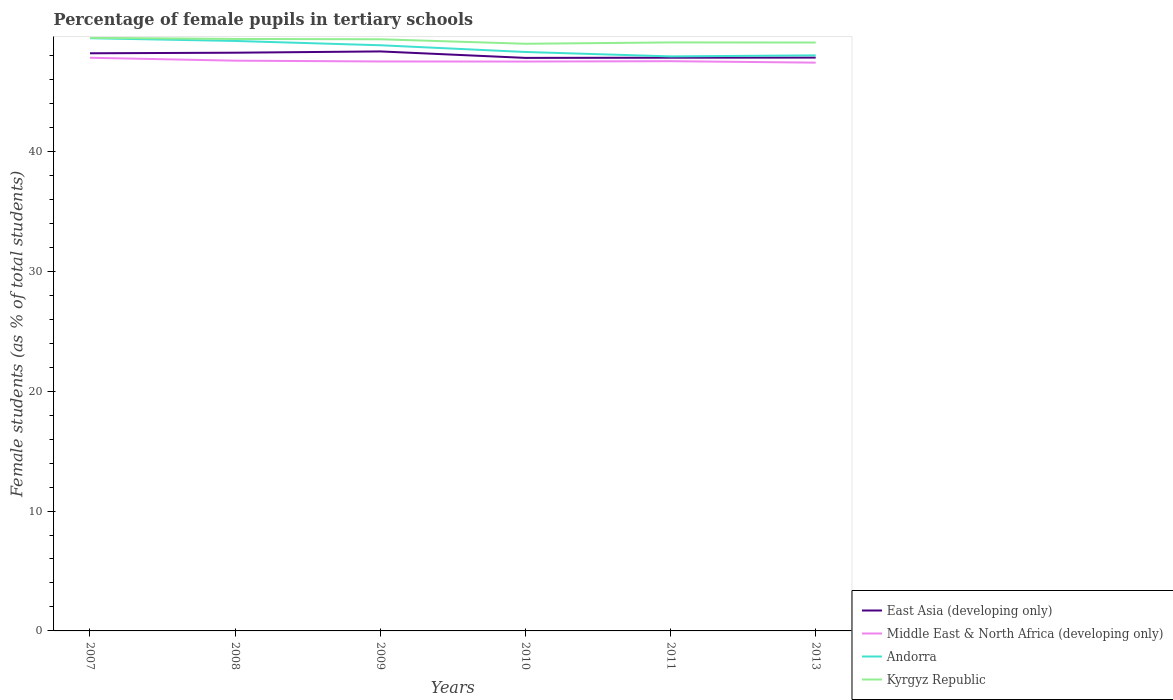How many different coloured lines are there?
Make the answer very short. 4. Is the number of lines equal to the number of legend labels?
Keep it short and to the point. Yes. Across all years, what is the maximum percentage of female pupils in tertiary schools in East Asia (developing only)?
Your response must be concise. 47.8. What is the total percentage of female pupils in tertiary schools in East Asia (developing only) in the graph?
Make the answer very short. 0.36. What is the difference between the highest and the second highest percentage of female pupils in tertiary schools in East Asia (developing only)?
Your response must be concise. 0.54. Is the percentage of female pupils in tertiary schools in Kyrgyz Republic strictly greater than the percentage of female pupils in tertiary schools in Middle East & North Africa (developing only) over the years?
Your answer should be compact. No. How many lines are there?
Give a very brief answer. 4. How many years are there in the graph?
Give a very brief answer. 6. What is the difference between two consecutive major ticks on the Y-axis?
Offer a terse response. 10. Are the values on the major ticks of Y-axis written in scientific E-notation?
Give a very brief answer. No. Does the graph contain any zero values?
Keep it short and to the point. No. Does the graph contain grids?
Your answer should be compact. No. Where does the legend appear in the graph?
Keep it short and to the point. Bottom right. How many legend labels are there?
Ensure brevity in your answer.  4. What is the title of the graph?
Provide a succinct answer. Percentage of female pupils in tertiary schools. What is the label or title of the X-axis?
Make the answer very short. Years. What is the label or title of the Y-axis?
Provide a succinct answer. Female students (as % of total students). What is the Female students (as % of total students) of East Asia (developing only) in 2007?
Your answer should be compact. 48.18. What is the Female students (as % of total students) in Middle East & North Africa (developing only) in 2007?
Provide a succinct answer. 47.81. What is the Female students (as % of total students) of Andorra in 2007?
Provide a succinct answer. 49.44. What is the Female students (as % of total students) in Kyrgyz Republic in 2007?
Provide a short and direct response. 49.47. What is the Female students (as % of total students) of East Asia (developing only) in 2008?
Offer a terse response. 48.23. What is the Female students (as % of total students) of Middle East & North Africa (developing only) in 2008?
Provide a succinct answer. 47.56. What is the Female students (as % of total students) of Andorra in 2008?
Ensure brevity in your answer.  49.21. What is the Female students (as % of total students) in Kyrgyz Republic in 2008?
Keep it short and to the point. 49.37. What is the Female students (as % of total students) of East Asia (developing only) in 2009?
Give a very brief answer. 48.34. What is the Female students (as % of total students) of Middle East & North Africa (developing only) in 2009?
Your answer should be compact. 47.5. What is the Female students (as % of total students) in Andorra in 2009?
Provide a succinct answer. 48.85. What is the Female students (as % of total students) in Kyrgyz Republic in 2009?
Ensure brevity in your answer.  49.35. What is the Female students (as % of total students) in East Asia (developing only) in 2010?
Offer a terse response. 47.8. What is the Female students (as % of total students) of Middle East & North Africa (developing only) in 2010?
Give a very brief answer. 47.49. What is the Female students (as % of total students) of Andorra in 2010?
Provide a short and direct response. 48.29. What is the Female students (as % of total students) in Kyrgyz Republic in 2010?
Keep it short and to the point. 48.97. What is the Female students (as % of total students) in East Asia (developing only) in 2011?
Your response must be concise. 47.81. What is the Female students (as % of total students) in Middle East & North Africa (developing only) in 2011?
Make the answer very short. 47.52. What is the Female students (as % of total students) of Andorra in 2011?
Your answer should be compact. 47.92. What is the Female students (as % of total students) of Kyrgyz Republic in 2011?
Make the answer very short. 49.09. What is the Female students (as % of total students) of East Asia (developing only) in 2013?
Ensure brevity in your answer.  47.82. What is the Female students (as % of total students) of Middle East & North Africa (developing only) in 2013?
Ensure brevity in your answer.  47.4. What is the Female students (as % of total students) of Andorra in 2013?
Keep it short and to the point. 48.01. What is the Female students (as % of total students) of Kyrgyz Republic in 2013?
Ensure brevity in your answer.  49.08. Across all years, what is the maximum Female students (as % of total students) of East Asia (developing only)?
Your answer should be compact. 48.34. Across all years, what is the maximum Female students (as % of total students) in Middle East & North Africa (developing only)?
Make the answer very short. 47.81. Across all years, what is the maximum Female students (as % of total students) in Andorra?
Give a very brief answer. 49.44. Across all years, what is the maximum Female students (as % of total students) in Kyrgyz Republic?
Offer a terse response. 49.47. Across all years, what is the minimum Female students (as % of total students) of East Asia (developing only)?
Provide a short and direct response. 47.8. Across all years, what is the minimum Female students (as % of total students) of Middle East & North Africa (developing only)?
Make the answer very short. 47.4. Across all years, what is the minimum Female students (as % of total students) in Andorra?
Give a very brief answer. 47.92. Across all years, what is the minimum Female students (as % of total students) of Kyrgyz Republic?
Offer a terse response. 48.97. What is the total Female students (as % of total students) of East Asia (developing only) in the graph?
Offer a terse response. 288.17. What is the total Female students (as % of total students) of Middle East & North Africa (developing only) in the graph?
Provide a succinct answer. 285.28. What is the total Female students (as % of total students) in Andorra in the graph?
Provide a succinct answer. 291.71. What is the total Female students (as % of total students) in Kyrgyz Republic in the graph?
Keep it short and to the point. 295.33. What is the difference between the Female students (as % of total students) of East Asia (developing only) in 2007 and that in 2008?
Give a very brief answer. -0.05. What is the difference between the Female students (as % of total students) of Middle East & North Africa (developing only) in 2007 and that in 2008?
Your answer should be compact. 0.24. What is the difference between the Female students (as % of total students) of Andorra in 2007 and that in 2008?
Offer a terse response. 0.23. What is the difference between the Female students (as % of total students) in Kyrgyz Republic in 2007 and that in 2008?
Give a very brief answer. 0.1. What is the difference between the Female students (as % of total students) in East Asia (developing only) in 2007 and that in 2009?
Offer a terse response. -0.15. What is the difference between the Female students (as % of total students) of Middle East & North Africa (developing only) in 2007 and that in 2009?
Provide a succinct answer. 0.31. What is the difference between the Female students (as % of total students) of Andorra in 2007 and that in 2009?
Your response must be concise. 0.59. What is the difference between the Female students (as % of total students) of Kyrgyz Republic in 2007 and that in 2009?
Offer a very short reply. 0.12. What is the difference between the Female students (as % of total students) in East Asia (developing only) in 2007 and that in 2010?
Provide a short and direct response. 0.39. What is the difference between the Female students (as % of total students) in Middle East & North Africa (developing only) in 2007 and that in 2010?
Your answer should be compact. 0.32. What is the difference between the Female students (as % of total students) of Andorra in 2007 and that in 2010?
Your answer should be compact. 1.15. What is the difference between the Female students (as % of total students) in Kyrgyz Republic in 2007 and that in 2010?
Offer a very short reply. 0.5. What is the difference between the Female students (as % of total students) of East Asia (developing only) in 2007 and that in 2011?
Your response must be concise. 0.37. What is the difference between the Female students (as % of total students) of Middle East & North Africa (developing only) in 2007 and that in 2011?
Provide a succinct answer. 0.29. What is the difference between the Female students (as % of total students) in Andorra in 2007 and that in 2011?
Give a very brief answer. 1.52. What is the difference between the Female students (as % of total students) of Kyrgyz Republic in 2007 and that in 2011?
Your response must be concise. 0.38. What is the difference between the Female students (as % of total students) of East Asia (developing only) in 2007 and that in 2013?
Offer a very short reply. 0.36. What is the difference between the Female students (as % of total students) of Middle East & North Africa (developing only) in 2007 and that in 2013?
Keep it short and to the point. 0.41. What is the difference between the Female students (as % of total students) in Andorra in 2007 and that in 2013?
Keep it short and to the point. 1.43. What is the difference between the Female students (as % of total students) in Kyrgyz Republic in 2007 and that in 2013?
Your answer should be compact. 0.39. What is the difference between the Female students (as % of total students) of East Asia (developing only) in 2008 and that in 2009?
Your response must be concise. -0.11. What is the difference between the Female students (as % of total students) of Middle East & North Africa (developing only) in 2008 and that in 2009?
Your answer should be very brief. 0.07. What is the difference between the Female students (as % of total students) in Andorra in 2008 and that in 2009?
Provide a succinct answer. 0.36. What is the difference between the Female students (as % of total students) of Kyrgyz Republic in 2008 and that in 2009?
Give a very brief answer. 0.02. What is the difference between the Female students (as % of total students) of East Asia (developing only) in 2008 and that in 2010?
Ensure brevity in your answer.  0.43. What is the difference between the Female students (as % of total students) in Middle East & North Africa (developing only) in 2008 and that in 2010?
Offer a very short reply. 0.07. What is the difference between the Female students (as % of total students) in Andorra in 2008 and that in 2010?
Your response must be concise. 0.92. What is the difference between the Female students (as % of total students) of Kyrgyz Republic in 2008 and that in 2010?
Your answer should be very brief. 0.4. What is the difference between the Female students (as % of total students) of East Asia (developing only) in 2008 and that in 2011?
Provide a short and direct response. 0.42. What is the difference between the Female students (as % of total students) of Middle East & North Africa (developing only) in 2008 and that in 2011?
Provide a succinct answer. 0.04. What is the difference between the Female students (as % of total students) of Andorra in 2008 and that in 2011?
Your response must be concise. 1.29. What is the difference between the Female students (as % of total students) in Kyrgyz Republic in 2008 and that in 2011?
Your response must be concise. 0.29. What is the difference between the Female students (as % of total students) of East Asia (developing only) in 2008 and that in 2013?
Provide a succinct answer. 0.41. What is the difference between the Female students (as % of total students) in Middle East & North Africa (developing only) in 2008 and that in 2013?
Keep it short and to the point. 0.17. What is the difference between the Female students (as % of total students) of Andorra in 2008 and that in 2013?
Make the answer very short. 1.2. What is the difference between the Female students (as % of total students) of Kyrgyz Republic in 2008 and that in 2013?
Your answer should be compact. 0.3. What is the difference between the Female students (as % of total students) in East Asia (developing only) in 2009 and that in 2010?
Make the answer very short. 0.54. What is the difference between the Female students (as % of total students) of Middle East & North Africa (developing only) in 2009 and that in 2010?
Offer a terse response. 0.01. What is the difference between the Female students (as % of total students) of Andorra in 2009 and that in 2010?
Keep it short and to the point. 0.56. What is the difference between the Female students (as % of total students) of Kyrgyz Republic in 2009 and that in 2010?
Ensure brevity in your answer.  0.38. What is the difference between the Female students (as % of total students) of East Asia (developing only) in 2009 and that in 2011?
Your answer should be very brief. 0.52. What is the difference between the Female students (as % of total students) of Middle East & North Africa (developing only) in 2009 and that in 2011?
Offer a very short reply. -0.02. What is the difference between the Female students (as % of total students) of Andorra in 2009 and that in 2011?
Provide a succinct answer. 0.93. What is the difference between the Female students (as % of total students) of Kyrgyz Republic in 2009 and that in 2011?
Make the answer very short. 0.26. What is the difference between the Female students (as % of total students) in East Asia (developing only) in 2009 and that in 2013?
Give a very brief answer. 0.52. What is the difference between the Female students (as % of total students) of Middle East & North Africa (developing only) in 2009 and that in 2013?
Give a very brief answer. 0.1. What is the difference between the Female students (as % of total students) in Andorra in 2009 and that in 2013?
Offer a very short reply. 0.84. What is the difference between the Female students (as % of total students) in Kyrgyz Republic in 2009 and that in 2013?
Provide a succinct answer. 0.27. What is the difference between the Female students (as % of total students) in East Asia (developing only) in 2010 and that in 2011?
Provide a short and direct response. -0.02. What is the difference between the Female students (as % of total students) in Middle East & North Africa (developing only) in 2010 and that in 2011?
Your response must be concise. -0.03. What is the difference between the Female students (as % of total students) in Andorra in 2010 and that in 2011?
Offer a terse response. 0.37. What is the difference between the Female students (as % of total students) in Kyrgyz Republic in 2010 and that in 2011?
Your answer should be compact. -0.11. What is the difference between the Female students (as % of total students) in East Asia (developing only) in 2010 and that in 2013?
Provide a short and direct response. -0.02. What is the difference between the Female students (as % of total students) in Middle East & North Africa (developing only) in 2010 and that in 2013?
Your answer should be compact. 0.09. What is the difference between the Female students (as % of total students) of Andorra in 2010 and that in 2013?
Offer a terse response. 0.28. What is the difference between the Female students (as % of total students) in Kyrgyz Republic in 2010 and that in 2013?
Provide a succinct answer. -0.1. What is the difference between the Female students (as % of total students) of East Asia (developing only) in 2011 and that in 2013?
Make the answer very short. -0.01. What is the difference between the Female students (as % of total students) in Middle East & North Africa (developing only) in 2011 and that in 2013?
Provide a succinct answer. 0.12. What is the difference between the Female students (as % of total students) of Andorra in 2011 and that in 2013?
Your answer should be compact. -0.09. What is the difference between the Female students (as % of total students) in Kyrgyz Republic in 2011 and that in 2013?
Give a very brief answer. 0.01. What is the difference between the Female students (as % of total students) of East Asia (developing only) in 2007 and the Female students (as % of total students) of Middle East & North Africa (developing only) in 2008?
Ensure brevity in your answer.  0.62. What is the difference between the Female students (as % of total students) in East Asia (developing only) in 2007 and the Female students (as % of total students) in Andorra in 2008?
Provide a succinct answer. -1.03. What is the difference between the Female students (as % of total students) of East Asia (developing only) in 2007 and the Female students (as % of total students) of Kyrgyz Republic in 2008?
Offer a terse response. -1.19. What is the difference between the Female students (as % of total students) in Middle East & North Africa (developing only) in 2007 and the Female students (as % of total students) in Andorra in 2008?
Your response must be concise. -1.4. What is the difference between the Female students (as % of total students) of Middle East & North Africa (developing only) in 2007 and the Female students (as % of total students) of Kyrgyz Republic in 2008?
Give a very brief answer. -1.57. What is the difference between the Female students (as % of total students) of Andorra in 2007 and the Female students (as % of total students) of Kyrgyz Republic in 2008?
Offer a terse response. 0.06. What is the difference between the Female students (as % of total students) in East Asia (developing only) in 2007 and the Female students (as % of total students) in Middle East & North Africa (developing only) in 2009?
Offer a terse response. 0.68. What is the difference between the Female students (as % of total students) of East Asia (developing only) in 2007 and the Female students (as % of total students) of Andorra in 2009?
Give a very brief answer. -0.67. What is the difference between the Female students (as % of total students) of East Asia (developing only) in 2007 and the Female students (as % of total students) of Kyrgyz Republic in 2009?
Your answer should be compact. -1.17. What is the difference between the Female students (as % of total students) of Middle East & North Africa (developing only) in 2007 and the Female students (as % of total students) of Andorra in 2009?
Provide a short and direct response. -1.04. What is the difference between the Female students (as % of total students) in Middle East & North Africa (developing only) in 2007 and the Female students (as % of total students) in Kyrgyz Republic in 2009?
Your answer should be very brief. -1.54. What is the difference between the Female students (as % of total students) of Andorra in 2007 and the Female students (as % of total students) of Kyrgyz Republic in 2009?
Your answer should be very brief. 0.09. What is the difference between the Female students (as % of total students) of East Asia (developing only) in 2007 and the Female students (as % of total students) of Middle East & North Africa (developing only) in 2010?
Offer a terse response. 0.69. What is the difference between the Female students (as % of total students) of East Asia (developing only) in 2007 and the Female students (as % of total students) of Andorra in 2010?
Your response must be concise. -0.11. What is the difference between the Female students (as % of total students) in East Asia (developing only) in 2007 and the Female students (as % of total students) in Kyrgyz Republic in 2010?
Keep it short and to the point. -0.79. What is the difference between the Female students (as % of total students) in Middle East & North Africa (developing only) in 2007 and the Female students (as % of total students) in Andorra in 2010?
Ensure brevity in your answer.  -0.48. What is the difference between the Female students (as % of total students) of Middle East & North Africa (developing only) in 2007 and the Female students (as % of total students) of Kyrgyz Republic in 2010?
Keep it short and to the point. -1.17. What is the difference between the Female students (as % of total students) of Andorra in 2007 and the Female students (as % of total students) of Kyrgyz Republic in 2010?
Offer a very short reply. 0.46. What is the difference between the Female students (as % of total students) in East Asia (developing only) in 2007 and the Female students (as % of total students) in Middle East & North Africa (developing only) in 2011?
Offer a terse response. 0.66. What is the difference between the Female students (as % of total students) of East Asia (developing only) in 2007 and the Female students (as % of total students) of Andorra in 2011?
Give a very brief answer. 0.26. What is the difference between the Female students (as % of total students) of East Asia (developing only) in 2007 and the Female students (as % of total students) of Kyrgyz Republic in 2011?
Ensure brevity in your answer.  -0.91. What is the difference between the Female students (as % of total students) of Middle East & North Africa (developing only) in 2007 and the Female students (as % of total students) of Andorra in 2011?
Provide a short and direct response. -0.11. What is the difference between the Female students (as % of total students) in Middle East & North Africa (developing only) in 2007 and the Female students (as % of total students) in Kyrgyz Republic in 2011?
Keep it short and to the point. -1.28. What is the difference between the Female students (as % of total students) in Andorra in 2007 and the Female students (as % of total students) in Kyrgyz Republic in 2011?
Keep it short and to the point. 0.35. What is the difference between the Female students (as % of total students) in East Asia (developing only) in 2007 and the Female students (as % of total students) in Middle East & North Africa (developing only) in 2013?
Give a very brief answer. 0.78. What is the difference between the Female students (as % of total students) in East Asia (developing only) in 2007 and the Female students (as % of total students) in Andorra in 2013?
Provide a succinct answer. 0.17. What is the difference between the Female students (as % of total students) of East Asia (developing only) in 2007 and the Female students (as % of total students) of Kyrgyz Republic in 2013?
Your answer should be very brief. -0.9. What is the difference between the Female students (as % of total students) in Middle East & North Africa (developing only) in 2007 and the Female students (as % of total students) in Kyrgyz Republic in 2013?
Make the answer very short. -1.27. What is the difference between the Female students (as % of total students) in Andorra in 2007 and the Female students (as % of total students) in Kyrgyz Republic in 2013?
Give a very brief answer. 0.36. What is the difference between the Female students (as % of total students) of East Asia (developing only) in 2008 and the Female students (as % of total students) of Middle East & North Africa (developing only) in 2009?
Give a very brief answer. 0.73. What is the difference between the Female students (as % of total students) in East Asia (developing only) in 2008 and the Female students (as % of total students) in Andorra in 2009?
Your answer should be very brief. -0.62. What is the difference between the Female students (as % of total students) of East Asia (developing only) in 2008 and the Female students (as % of total students) of Kyrgyz Republic in 2009?
Ensure brevity in your answer.  -1.12. What is the difference between the Female students (as % of total students) of Middle East & North Africa (developing only) in 2008 and the Female students (as % of total students) of Andorra in 2009?
Offer a terse response. -1.29. What is the difference between the Female students (as % of total students) in Middle East & North Africa (developing only) in 2008 and the Female students (as % of total students) in Kyrgyz Republic in 2009?
Ensure brevity in your answer.  -1.78. What is the difference between the Female students (as % of total students) of Andorra in 2008 and the Female students (as % of total students) of Kyrgyz Republic in 2009?
Ensure brevity in your answer.  -0.14. What is the difference between the Female students (as % of total students) in East Asia (developing only) in 2008 and the Female students (as % of total students) in Middle East & North Africa (developing only) in 2010?
Give a very brief answer. 0.74. What is the difference between the Female students (as % of total students) in East Asia (developing only) in 2008 and the Female students (as % of total students) in Andorra in 2010?
Offer a terse response. -0.06. What is the difference between the Female students (as % of total students) in East Asia (developing only) in 2008 and the Female students (as % of total students) in Kyrgyz Republic in 2010?
Make the answer very short. -0.75. What is the difference between the Female students (as % of total students) of Middle East & North Africa (developing only) in 2008 and the Female students (as % of total students) of Andorra in 2010?
Your answer should be very brief. -0.72. What is the difference between the Female students (as % of total students) of Middle East & North Africa (developing only) in 2008 and the Female students (as % of total students) of Kyrgyz Republic in 2010?
Provide a succinct answer. -1.41. What is the difference between the Female students (as % of total students) of Andorra in 2008 and the Female students (as % of total students) of Kyrgyz Republic in 2010?
Make the answer very short. 0.23. What is the difference between the Female students (as % of total students) of East Asia (developing only) in 2008 and the Female students (as % of total students) of Middle East & North Africa (developing only) in 2011?
Your answer should be very brief. 0.71. What is the difference between the Female students (as % of total students) of East Asia (developing only) in 2008 and the Female students (as % of total students) of Andorra in 2011?
Offer a very short reply. 0.31. What is the difference between the Female students (as % of total students) of East Asia (developing only) in 2008 and the Female students (as % of total students) of Kyrgyz Republic in 2011?
Provide a succinct answer. -0.86. What is the difference between the Female students (as % of total students) of Middle East & North Africa (developing only) in 2008 and the Female students (as % of total students) of Andorra in 2011?
Offer a very short reply. -0.36. What is the difference between the Female students (as % of total students) of Middle East & North Africa (developing only) in 2008 and the Female students (as % of total students) of Kyrgyz Republic in 2011?
Make the answer very short. -1.52. What is the difference between the Female students (as % of total students) in Andorra in 2008 and the Female students (as % of total students) in Kyrgyz Republic in 2011?
Offer a terse response. 0.12. What is the difference between the Female students (as % of total students) of East Asia (developing only) in 2008 and the Female students (as % of total students) of Middle East & North Africa (developing only) in 2013?
Your answer should be very brief. 0.83. What is the difference between the Female students (as % of total students) of East Asia (developing only) in 2008 and the Female students (as % of total students) of Andorra in 2013?
Keep it short and to the point. 0.22. What is the difference between the Female students (as % of total students) in East Asia (developing only) in 2008 and the Female students (as % of total students) in Kyrgyz Republic in 2013?
Your response must be concise. -0.85. What is the difference between the Female students (as % of total students) of Middle East & North Africa (developing only) in 2008 and the Female students (as % of total students) of Andorra in 2013?
Offer a very short reply. -0.44. What is the difference between the Female students (as % of total students) of Middle East & North Africa (developing only) in 2008 and the Female students (as % of total students) of Kyrgyz Republic in 2013?
Offer a terse response. -1.51. What is the difference between the Female students (as % of total students) of Andorra in 2008 and the Female students (as % of total students) of Kyrgyz Republic in 2013?
Keep it short and to the point. 0.13. What is the difference between the Female students (as % of total students) in East Asia (developing only) in 2009 and the Female students (as % of total students) in Middle East & North Africa (developing only) in 2010?
Your response must be concise. 0.84. What is the difference between the Female students (as % of total students) in East Asia (developing only) in 2009 and the Female students (as % of total students) in Andorra in 2010?
Give a very brief answer. 0.05. What is the difference between the Female students (as % of total students) of East Asia (developing only) in 2009 and the Female students (as % of total students) of Kyrgyz Republic in 2010?
Provide a short and direct response. -0.64. What is the difference between the Female students (as % of total students) in Middle East & North Africa (developing only) in 2009 and the Female students (as % of total students) in Andorra in 2010?
Give a very brief answer. -0.79. What is the difference between the Female students (as % of total students) of Middle East & North Africa (developing only) in 2009 and the Female students (as % of total students) of Kyrgyz Republic in 2010?
Provide a succinct answer. -1.48. What is the difference between the Female students (as % of total students) of Andorra in 2009 and the Female students (as % of total students) of Kyrgyz Republic in 2010?
Provide a short and direct response. -0.12. What is the difference between the Female students (as % of total students) of East Asia (developing only) in 2009 and the Female students (as % of total students) of Middle East & North Africa (developing only) in 2011?
Offer a terse response. 0.81. What is the difference between the Female students (as % of total students) in East Asia (developing only) in 2009 and the Female students (as % of total students) in Andorra in 2011?
Provide a succinct answer. 0.41. What is the difference between the Female students (as % of total students) in East Asia (developing only) in 2009 and the Female students (as % of total students) in Kyrgyz Republic in 2011?
Make the answer very short. -0.75. What is the difference between the Female students (as % of total students) in Middle East & North Africa (developing only) in 2009 and the Female students (as % of total students) in Andorra in 2011?
Offer a very short reply. -0.42. What is the difference between the Female students (as % of total students) of Middle East & North Africa (developing only) in 2009 and the Female students (as % of total students) of Kyrgyz Republic in 2011?
Provide a succinct answer. -1.59. What is the difference between the Female students (as % of total students) of Andorra in 2009 and the Female students (as % of total students) of Kyrgyz Republic in 2011?
Your answer should be very brief. -0.24. What is the difference between the Female students (as % of total students) of East Asia (developing only) in 2009 and the Female students (as % of total students) of Middle East & North Africa (developing only) in 2013?
Ensure brevity in your answer.  0.94. What is the difference between the Female students (as % of total students) of East Asia (developing only) in 2009 and the Female students (as % of total students) of Andorra in 2013?
Your response must be concise. 0.33. What is the difference between the Female students (as % of total students) of East Asia (developing only) in 2009 and the Female students (as % of total students) of Kyrgyz Republic in 2013?
Make the answer very short. -0.74. What is the difference between the Female students (as % of total students) in Middle East & North Africa (developing only) in 2009 and the Female students (as % of total students) in Andorra in 2013?
Make the answer very short. -0.51. What is the difference between the Female students (as % of total students) in Middle East & North Africa (developing only) in 2009 and the Female students (as % of total students) in Kyrgyz Republic in 2013?
Make the answer very short. -1.58. What is the difference between the Female students (as % of total students) in Andorra in 2009 and the Female students (as % of total students) in Kyrgyz Republic in 2013?
Offer a terse response. -0.23. What is the difference between the Female students (as % of total students) in East Asia (developing only) in 2010 and the Female students (as % of total students) in Middle East & North Africa (developing only) in 2011?
Provide a short and direct response. 0.27. What is the difference between the Female students (as % of total students) in East Asia (developing only) in 2010 and the Female students (as % of total students) in Andorra in 2011?
Make the answer very short. -0.13. What is the difference between the Female students (as % of total students) in East Asia (developing only) in 2010 and the Female students (as % of total students) in Kyrgyz Republic in 2011?
Make the answer very short. -1.29. What is the difference between the Female students (as % of total students) of Middle East & North Africa (developing only) in 2010 and the Female students (as % of total students) of Andorra in 2011?
Offer a terse response. -0.43. What is the difference between the Female students (as % of total students) of Middle East & North Africa (developing only) in 2010 and the Female students (as % of total students) of Kyrgyz Republic in 2011?
Provide a succinct answer. -1.6. What is the difference between the Female students (as % of total students) of Andorra in 2010 and the Female students (as % of total students) of Kyrgyz Republic in 2011?
Keep it short and to the point. -0.8. What is the difference between the Female students (as % of total students) in East Asia (developing only) in 2010 and the Female students (as % of total students) in Middle East & North Africa (developing only) in 2013?
Offer a terse response. 0.4. What is the difference between the Female students (as % of total students) in East Asia (developing only) in 2010 and the Female students (as % of total students) in Andorra in 2013?
Give a very brief answer. -0.21. What is the difference between the Female students (as % of total students) of East Asia (developing only) in 2010 and the Female students (as % of total students) of Kyrgyz Republic in 2013?
Provide a short and direct response. -1.28. What is the difference between the Female students (as % of total students) in Middle East & North Africa (developing only) in 2010 and the Female students (as % of total students) in Andorra in 2013?
Make the answer very short. -0.52. What is the difference between the Female students (as % of total students) of Middle East & North Africa (developing only) in 2010 and the Female students (as % of total students) of Kyrgyz Republic in 2013?
Keep it short and to the point. -1.59. What is the difference between the Female students (as % of total students) in Andorra in 2010 and the Female students (as % of total students) in Kyrgyz Republic in 2013?
Make the answer very short. -0.79. What is the difference between the Female students (as % of total students) in East Asia (developing only) in 2011 and the Female students (as % of total students) in Middle East & North Africa (developing only) in 2013?
Ensure brevity in your answer.  0.41. What is the difference between the Female students (as % of total students) of East Asia (developing only) in 2011 and the Female students (as % of total students) of Andorra in 2013?
Keep it short and to the point. -0.19. What is the difference between the Female students (as % of total students) of East Asia (developing only) in 2011 and the Female students (as % of total students) of Kyrgyz Republic in 2013?
Your answer should be compact. -1.27. What is the difference between the Female students (as % of total students) in Middle East & North Africa (developing only) in 2011 and the Female students (as % of total students) in Andorra in 2013?
Offer a very short reply. -0.49. What is the difference between the Female students (as % of total students) in Middle East & North Africa (developing only) in 2011 and the Female students (as % of total students) in Kyrgyz Republic in 2013?
Provide a short and direct response. -1.56. What is the difference between the Female students (as % of total students) of Andorra in 2011 and the Female students (as % of total students) of Kyrgyz Republic in 2013?
Offer a very short reply. -1.16. What is the average Female students (as % of total students) of East Asia (developing only) per year?
Offer a terse response. 48.03. What is the average Female students (as % of total students) in Middle East & North Africa (developing only) per year?
Your answer should be very brief. 47.55. What is the average Female students (as % of total students) of Andorra per year?
Your answer should be very brief. 48.62. What is the average Female students (as % of total students) of Kyrgyz Republic per year?
Your answer should be compact. 49.22. In the year 2007, what is the difference between the Female students (as % of total students) of East Asia (developing only) and Female students (as % of total students) of Middle East & North Africa (developing only)?
Ensure brevity in your answer.  0.37. In the year 2007, what is the difference between the Female students (as % of total students) of East Asia (developing only) and Female students (as % of total students) of Andorra?
Keep it short and to the point. -1.26. In the year 2007, what is the difference between the Female students (as % of total students) of East Asia (developing only) and Female students (as % of total students) of Kyrgyz Republic?
Provide a succinct answer. -1.29. In the year 2007, what is the difference between the Female students (as % of total students) of Middle East & North Africa (developing only) and Female students (as % of total students) of Andorra?
Give a very brief answer. -1.63. In the year 2007, what is the difference between the Female students (as % of total students) of Middle East & North Africa (developing only) and Female students (as % of total students) of Kyrgyz Republic?
Provide a short and direct response. -1.66. In the year 2007, what is the difference between the Female students (as % of total students) of Andorra and Female students (as % of total students) of Kyrgyz Republic?
Provide a succinct answer. -0.03. In the year 2008, what is the difference between the Female students (as % of total students) in East Asia (developing only) and Female students (as % of total students) in Middle East & North Africa (developing only)?
Make the answer very short. 0.66. In the year 2008, what is the difference between the Female students (as % of total students) in East Asia (developing only) and Female students (as % of total students) in Andorra?
Keep it short and to the point. -0.98. In the year 2008, what is the difference between the Female students (as % of total students) in East Asia (developing only) and Female students (as % of total students) in Kyrgyz Republic?
Your answer should be compact. -1.15. In the year 2008, what is the difference between the Female students (as % of total students) in Middle East & North Africa (developing only) and Female students (as % of total students) in Andorra?
Your answer should be compact. -1.64. In the year 2008, what is the difference between the Female students (as % of total students) of Middle East & North Africa (developing only) and Female students (as % of total students) of Kyrgyz Republic?
Your answer should be compact. -1.81. In the year 2008, what is the difference between the Female students (as % of total students) in Andorra and Female students (as % of total students) in Kyrgyz Republic?
Your answer should be compact. -0.17. In the year 2009, what is the difference between the Female students (as % of total students) of East Asia (developing only) and Female students (as % of total students) of Middle East & North Africa (developing only)?
Your answer should be compact. 0.84. In the year 2009, what is the difference between the Female students (as % of total students) of East Asia (developing only) and Female students (as % of total students) of Andorra?
Your answer should be very brief. -0.52. In the year 2009, what is the difference between the Female students (as % of total students) in East Asia (developing only) and Female students (as % of total students) in Kyrgyz Republic?
Your answer should be very brief. -1.01. In the year 2009, what is the difference between the Female students (as % of total students) of Middle East & North Africa (developing only) and Female students (as % of total students) of Andorra?
Ensure brevity in your answer.  -1.35. In the year 2009, what is the difference between the Female students (as % of total students) in Middle East & North Africa (developing only) and Female students (as % of total students) in Kyrgyz Republic?
Provide a short and direct response. -1.85. In the year 2009, what is the difference between the Female students (as % of total students) of Andorra and Female students (as % of total students) of Kyrgyz Republic?
Provide a succinct answer. -0.5. In the year 2010, what is the difference between the Female students (as % of total students) of East Asia (developing only) and Female students (as % of total students) of Middle East & North Africa (developing only)?
Your answer should be compact. 0.3. In the year 2010, what is the difference between the Female students (as % of total students) of East Asia (developing only) and Female students (as % of total students) of Andorra?
Your response must be concise. -0.49. In the year 2010, what is the difference between the Female students (as % of total students) in East Asia (developing only) and Female students (as % of total students) in Kyrgyz Republic?
Your response must be concise. -1.18. In the year 2010, what is the difference between the Female students (as % of total students) of Middle East & North Africa (developing only) and Female students (as % of total students) of Andorra?
Your answer should be very brief. -0.8. In the year 2010, what is the difference between the Female students (as % of total students) in Middle East & North Africa (developing only) and Female students (as % of total students) in Kyrgyz Republic?
Your response must be concise. -1.48. In the year 2010, what is the difference between the Female students (as % of total students) of Andorra and Female students (as % of total students) of Kyrgyz Republic?
Give a very brief answer. -0.69. In the year 2011, what is the difference between the Female students (as % of total students) of East Asia (developing only) and Female students (as % of total students) of Middle East & North Africa (developing only)?
Make the answer very short. 0.29. In the year 2011, what is the difference between the Female students (as % of total students) in East Asia (developing only) and Female students (as % of total students) in Andorra?
Your answer should be compact. -0.11. In the year 2011, what is the difference between the Female students (as % of total students) of East Asia (developing only) and Female students (as % of total students) of Kyrgyz Republic?
Your response must be concise. -1.27. In the year 2011, what is the difference between the Female students (as % of total students) in Middle East & North Africa (developing only) and Female students (as % of total students) in Andorra?
Keep it short and to the point. -0.4. In the year 2011, what is the difference between the Female students (as % of total students) of Middle East & North Africa (developing only) and Female students (as % of total students) of Kyrgyz Republic?
Your response must be concise. -1.57. In the year 2011, what is the difference between the Female students (as % of total students) of Andorra and Female students (as % of total students) of Kyrgyz Republic?
Ensure brevity in your answer.  -1.17. In the year 2013, what is the difference between the Female students (as % of total students) of East Asia (developing only) and Female students (as % of total students) of Middle East & North Africa (developing only)?
Offer a very short reply. 0.42. In the year 2013, what is the difference between the Female students (as % of total students) of East Asia (developing only) and Female students (as % of total students) of Andorra?
Your answer should be very brief. -0.19. In the year 2013, what is the difference between the Female students (as % of total students) of East Asia (developing only) and Female students (as % of total students) of Kyrgyz Republic?
Your response must be concise. -1.26. In the year 2013, what is the difference between the Female students (as % of total students) in Middle East & North Africa (developing only) and Female students (as % of total students) in Andorra?
Your answer should be compact. -0.61. In the year 2013, what is the difference between the Female students (as % of total students) of Middle East & North Africa (developing only) and Female students (as % of total students) of Kyrgyz Republic?
Offer a very short reply. -1.68. In the year 2013, what is the difference between the Female students (as % of total students) in Andorra and Female students (as % of total students) in Kyrgyz Republic?
Your response must be concise. -1.07. What is the ratio of the Female students (as % of total students) of East Asia (developing only) in 2007 to that in 2008?
Your answer should be very brief. 1. What is the ratio of the Female students (as % of total students) of Middle East & North Africa (developing only) in 2007 to that in 2009?
Make the answer very short. 1.01. What is the ratio of the Female students (as % of total students) in East Asia (developing only) in 2007 to that in 2010?
Provide a succinct answer. 1.01. What is the ratio of the Female students (as % of total students) of Andorra in 2007 to that in 2010?
Offer a terse response. 1.02. What is the ratio of the Female students (as % of total students) of Kyrgyz Republic in 2007 to that in 2010?
Keep it short and to the point. 1.01. What is the ratio of the Female students (as % of total students) in East Asia (developing only) in 2007 to that in 2011?
Make the answer very short. 1.01. What is the ratio of the Female students (as % of total students) in Middle East & North Africa (developing only) in 2007 to that in 2011?
Give a very brief answer. 1.01. What is the ratio of the Female students (as % of total students) in Andorra in 2007 to that in 2011?
Your response must be concise. 1.03. What is the ratio of the Female students (as % of total students) of East Asia (developing only) in 2007 to that in 2013?
Give a very brief answer. 1.01. What is the ratio of the Female students (as % of total students) of Middle East & North Africa (developing only) in 2007 to that in 2013?
Provide a succinct answer. 1.01. What is the ratio of the Female students (as % of total students) of Andorra in 2007 to that in 2013?
Offer a terse response. 1.03. What is the ratio of the Female students (as % of total students) of Kyrgyz Republic in 2007 to that in 2013?
Provide a short and direct response. 1.01. What is the ratio of the Female students (as % of total students) in Middle East & North Africa (developing only) in 2008 to that in 2009?
Your answer should be compact. 1. What is the ratio of the Female students (as % of total students) in Andorra in 2008 to that in 2009?
Provide a succinct answer. 1.01. What is the ratio of the Female students (as % of total students) of Kyrgyz Republic in 2008 to that in 2009?
Offer a very short reply. 1. What is the ratio of the Female students (as % of total students) of East Asia (developing only) in 2008 to that in 2010?
Ensure brevity in your answer.  1.01. What is the ratio of the Female students (as % of total students) in Andorra in 2008 to that in 2010?
Keep it short and to the point. 1.02. What is the ratio of the Female students (as % of total students) in Kyrgyz Republic in 2008 to that in 2010?
Give a very brief answer. 1.01. What is the ratio of the Female students (as % of total students) in East Asia (developing only) in 2008 to that in 2011?
Your answer should be very brief. 1.01. What is the ratio of the Female students (as % of total students) of Andorra in 2008 to that in 2011?
Your response must be concise. 1.03. What is the ratio of the Female students (as % of total students) in Kyrgyz Republic in 2008 to that in 2011?
Provide a succinct answer. 1.01. What is the ratio of the Female students (as % of total students) of East Asia (developing only) in 2008 to that in 2013?
Your response must be concise. 1.01. What is the ratio of the Female students (as % of total students) of Middle East & North Africa (developing only) in 2008 to that in 2013?
Offer a terse response. 1. What is the ratio of the Female students (as % of total students) in East Asia (developing only) in 2009 to that in 2010?
Provide a short and direct response. 1.01. What is the ratio of the Female students (as % of total students) of Andorra in 2009 to that in 2010?
Make the answer very short. 1.01. What is the ratio of the Female students (as % of total students) of Kyrgyz Republic in 2009 to that in 2010?
Your answer should be compact. 1.01. What is the ratio of the Female students (as % of total students) in East Asia (developing only) in 2009 to that in 2011?
Offer a terse response. 1.01. What is the ratio of the Female students (as % of total students) in Andorra in 2009 to that in 2011?
Offer a terse response. 1.02. What is the ratio of the Female students (as % of total students) of Kyrgyz Republic in 2009 to that in 2011?
Provide a succinct answer. 1.01. What is the ratio of the Female students (as % of total students) of East Asia (developing only) in 2009 to that in 2013?
Your response must be concise. 1.01. What is the ratio of the Female students (as % of total students) of Middle East & North Africa (developing only) in 2009 to that in 2013?
Keep it short and to the point. 1. What is the ratio of the Female students (as % of total students) in Andorra in 2009 to that in 2013?
Your answer should be compact. 1.02. What is the ratio of the Female students (as % of total students) of East Asia (developing only) in 2010 to that in 2011?
Your answer should be compact. 1. What is the ratio of the Female students (as % of total students) of Andorra in 2010 to that in 2011?
Provide a short and direct response. 1.01. What is the ratio of the Female students (as % of total students) in East Asia (developing only) in 2010 to that in 2013?
Offer a terse response. 1. What is the ratio of the Female students (as % of total students) of Middle East & North Africa (developing only) in 2010 to that in 2013?
Your response must be concise. 1. What is the ratio of the Female students (as % of total students) in Andorra in 2010 to that in 2013?
Your answer should be very brief. 1.01. What is the ratio of the Female students (as % of total students) of Kyrgyz Republic in 2010 to that in 2013?
Provide a succinct answer. 1. What is the ratio of the Female students (as % of total students) of Andorra in 2011 to that in 2013?
Offer a very short reply. 1. What is the ratio of the Female students (as % of total students) in Kyrgyz Republic in 2011 to that in 2013?
Keep it short and to the point. 1. What is the difference between the highest and the second highest Female students (as % of total students) in East Asia (developing only)?
Keep it short and to the point. 0.11. What is the difference between the highest and the second highest Female students (as % of total students) in Middle East & North Africa (developing only)?
Provide a succinct answer. 0.24. What is the difference between the highest and the second highest Female students (as % of total students) of Andorra?
Keep it short and to the point. 0.23. What is the difference between the highest and the second highest Female students (as % of total students) in Kyrgyz Republic?
Your answer should be very brief. 0.1. What is the difference between the highest and the lowest Female students (as % of total students) of East Asia (developing only)?
Your answer should be compact. 0.54. What is the difference between the highest and the lowest Female students (as % of total students) of Middle East & North Africa (developing only)?
Your answer should be compact. 0.41. What is the difference between the highest and the lowest Female students (as % of total students) of Andorra?
Offer a very short reply. 1.52. What is the difference between the highest and the lowest Female students (as % of total students) in Kyrgyz Republic?
Offer a terse response. 0.5. 